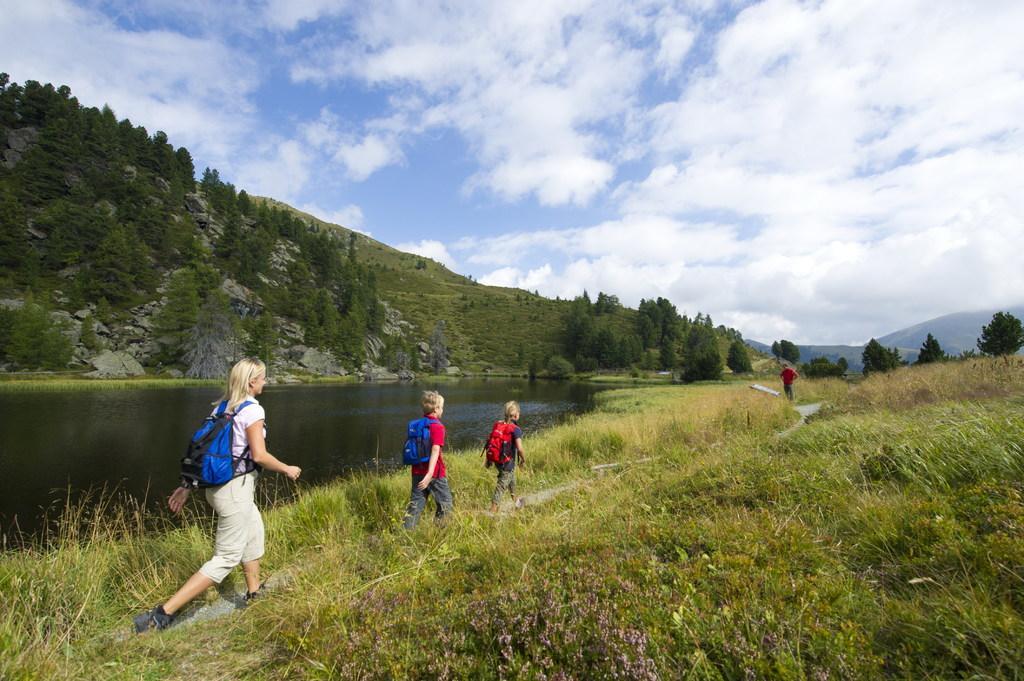Can you describe this image briefly? This is an outside view. Here I can see a woman and two children are wearing bags and walking on the ground. Here I can see the grass on the ground. On the left side there is a river. On the right side a person is standing. In the background, I can see few hills and trees. At the top of the image I can see the sky and clouds. 